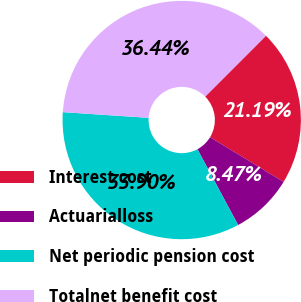<chart> <loc_0><loc_0><loc_500><loc_500><pie_chart><fcel>Interest cost<fcel>Actuarialloss<fcel>Net periodic pension cost<fcel>Totalnet benefit cost<nl><fcel>21.19%<fcel>8.47%<fcel>33.9%<fcel>36.44%<nl></chart> 